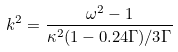Convert formula to latex. <formula><loc_0><loc_0><loc_500><loc_500>k ^ { 2 } = \frac { \omega ^ { 2 } - 1 } { \kappa ^ { 2 } ( 1 - 0 . 2 4 \Gamma ) / 3 \Gamma }</formula> 